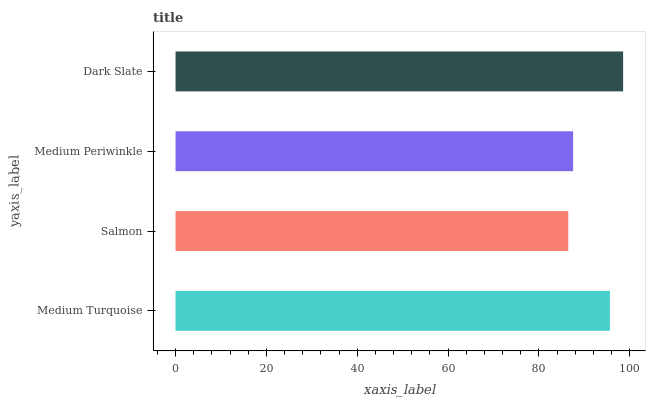Is Salmon the minimum?
Answer yes or no. Yes. Is Dark Slate the maximum?
Answer yes or no. Yes. Is Medium Periwinkle the minimum?
Answer yes or no. No. Is Medium Periwinkle the maximum?
Answer yes or no. No. Is Medium Periwinkle greater than Salmon?
Answer yes or no. Yes. Is Salmon less than Medium Periwinkle?
Answer yes or no. Yes. Is Salmon greater than Medium Periwinkle?
Answer yes or no. No. Is Medium Periwinkle less than Salmon?
Answer yes or no. No. Is Medium Turquoise the high median?
Answer yes or no. Yes. Is Medium Periwinkle the low median?
Answer yes or no. Yes. Is Dark Slate the high median?
Answer yes or no. No. Is Medium Turquoise the low median?
Answer yes or no. No. 